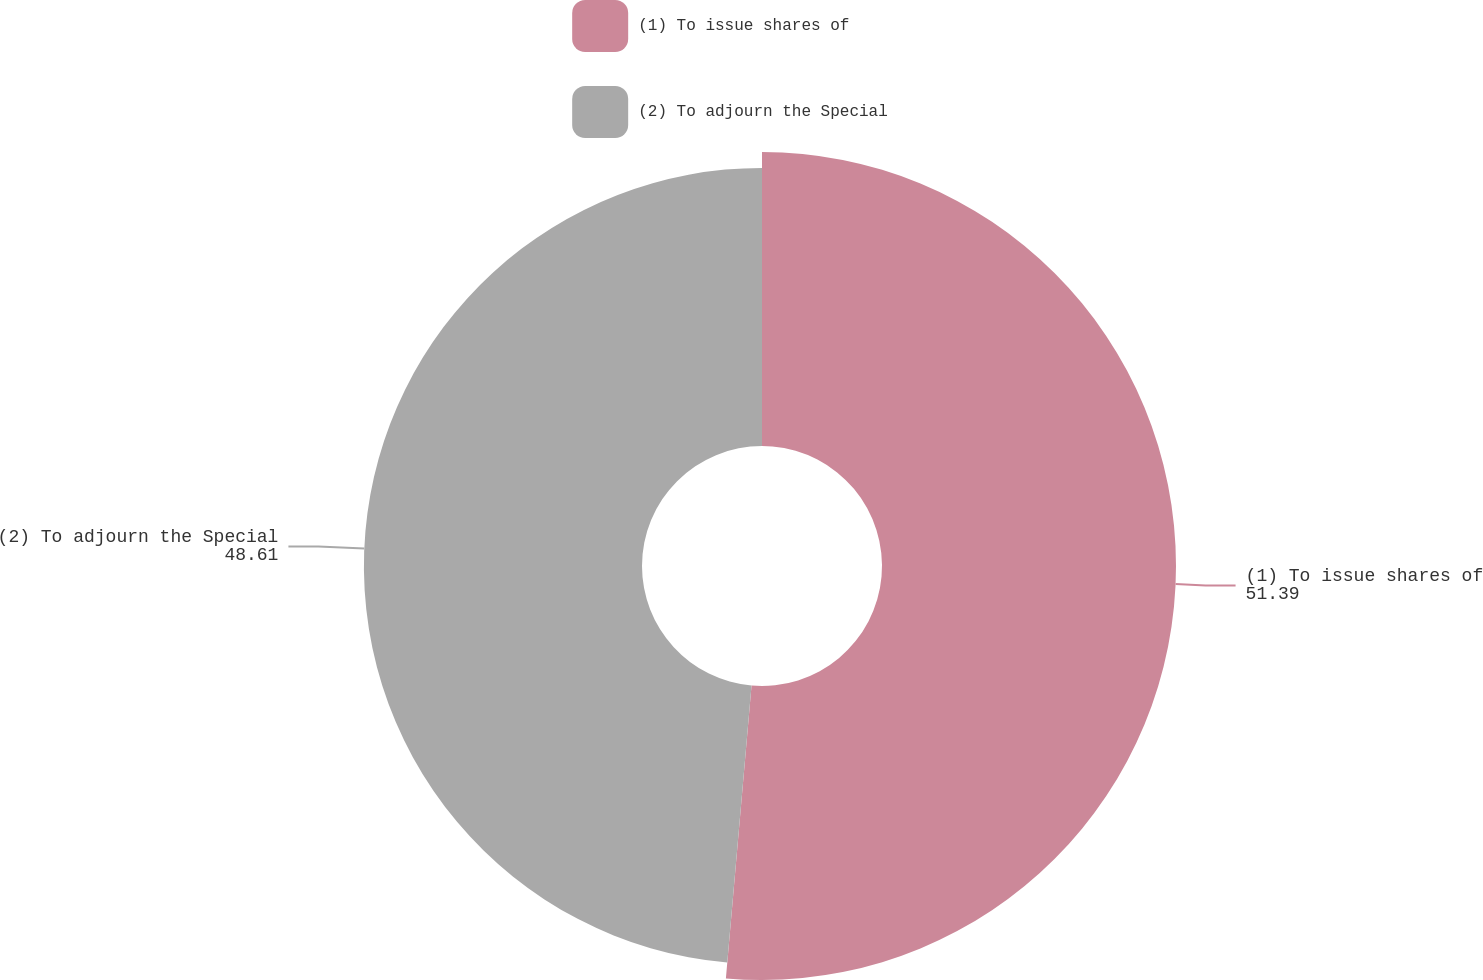Convert chart. <chart><loc_0><loc_0><loc_500><loc_500><pie_chart><fcel>(1) To issue shares of<fcel>(2) To adjourn the Special<nl><fcel>51.39%<fcel>48.61%<nl></chart> 